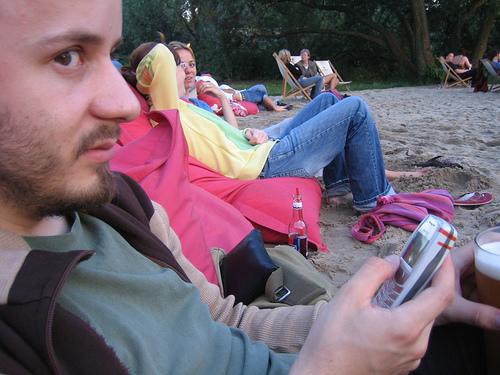Is this a new cell phone?
Concise answer only. No. How many people are having a conversation in the scene?
Short answer required. 2. Are there jeans in the image?
Write a very short answer. Yes. 